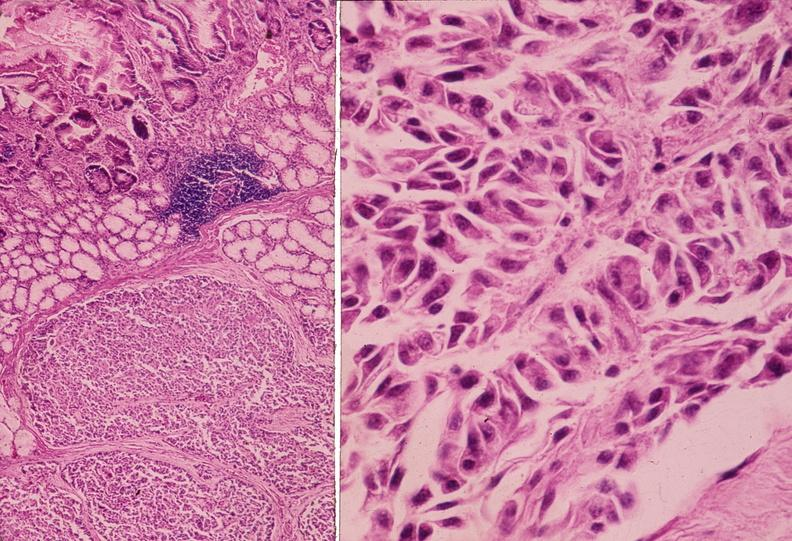what is present?
Answer the question using a single word or phrase. Pancreas 